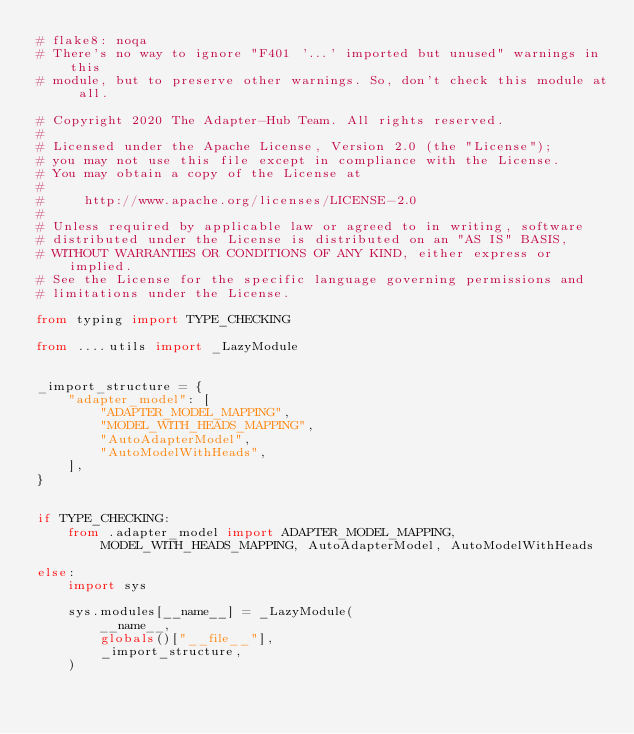Convert code to text. <code><loc_0><loc_0><loc_500><loc_500><_Python_># flake8: noqa
# There's no way to ignore "F401 '...' imported but unused" warnings in this
# module, but to preserve other warnings. So, don't check this module at all.

# Copyright 2020 The Adapter-Hub Team. All rights reserved.
#
# Licensed under the Apache License, Version 2.0 (the "License");
# you may not use this file except in compliance with the License.
# You may obtain a copy of the License at
#
#     http://www.apache.org/licenses/LICENSE-2.0
#
# Unless required by applicable law or agreed to in writing, software
# distributed under the License is distributed on an "AS IS" BASIS,
# WITHOUT WARRANTIES OR CONDITIONS OF ANY KIND, either express or implied.
# See the License for the specific language governing permissions and
# limitations under the License.

from typing import TYPE_CHECKING

from ....utils import _LazyModule


_import_structure = {
    "adapter_model": [
        "ADAPTER_MODEL_MAPPING",
        "MODEL_WITH_HEADS_MAPPING",
        "AutoAdapterModel",
        "AutoModelWithHeads",
    ],
}


if TYPE_CHECKING:
    from .adapter_model import ADAPTER_MODEL_MAPPING, MODEL_WITH_HEADS_MAPPING, AutoAdapterModel, AutoModelWithHeads

else:
    import sys

    sys.modules[__name__] = _LazyModule(
        __name__,
        globals()["__file__"],
        _import_structure,
    )
</code> 